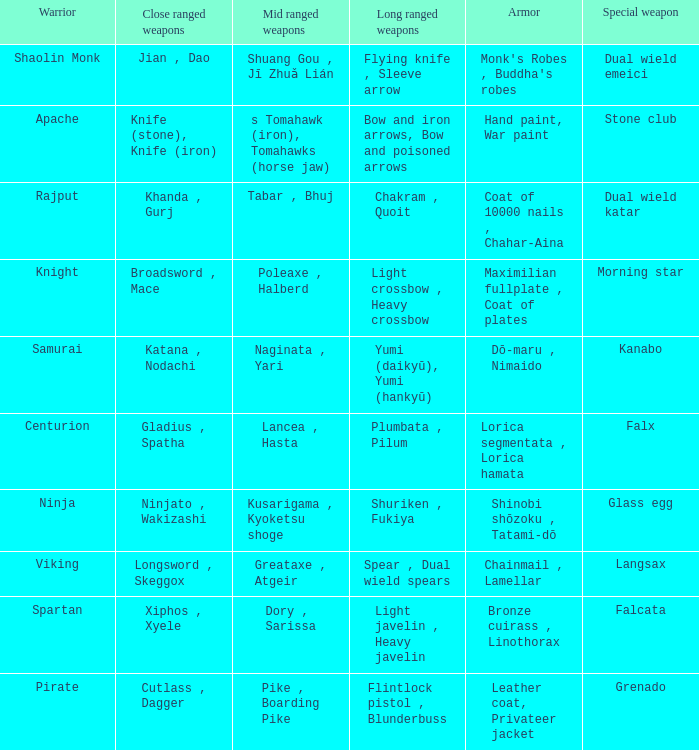If the Close ranged weapons are the knife (stone), knife (iron), what are the Long ranged weapons? Bow and iron arrows, Bow and poisoned arrows. 